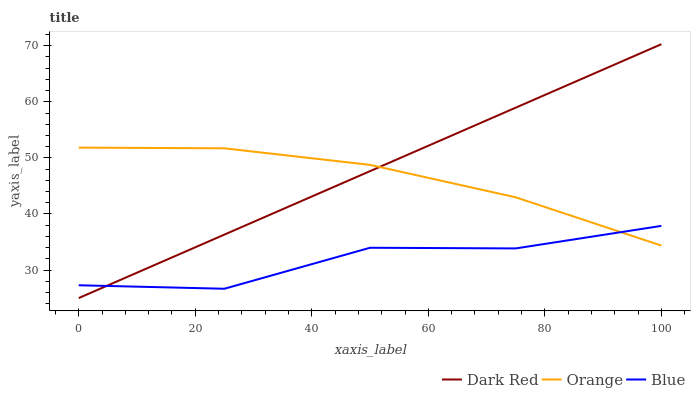Does Blue have the minimum area under the curve?
Answer yes or no. Yes. Does Dark Red have the maximum area under the curve?
Answer yes or no. Yes. Does Dark Red have the minimum area under the curve?
Answer yes or no. No. Does Blue have the maximum area under the curve?
Answer yes or no. No. Is Dark Red the smoothest?
Answer yes or no. Yes. Is Blue the roughest?
Answer yes or no. Yes. Is Blue the smoothest?
Answer yes or no. No. Is Dark Red the roughest?
Answer yes or no. No. Does Blue have the lowest value?
Answer yes or no. No. Does Dark Red have the highest value?
Answer yes or no. Yes. Does Blue have the highest value?
Answer yes or no. No. Does Orange intersect Dark Red?
Answer yes or no. Yes. Is Orange less than Dark Red?
Answer yes or no. No. Is Orange greater than Dark Red?
Answer yes or no. No. 